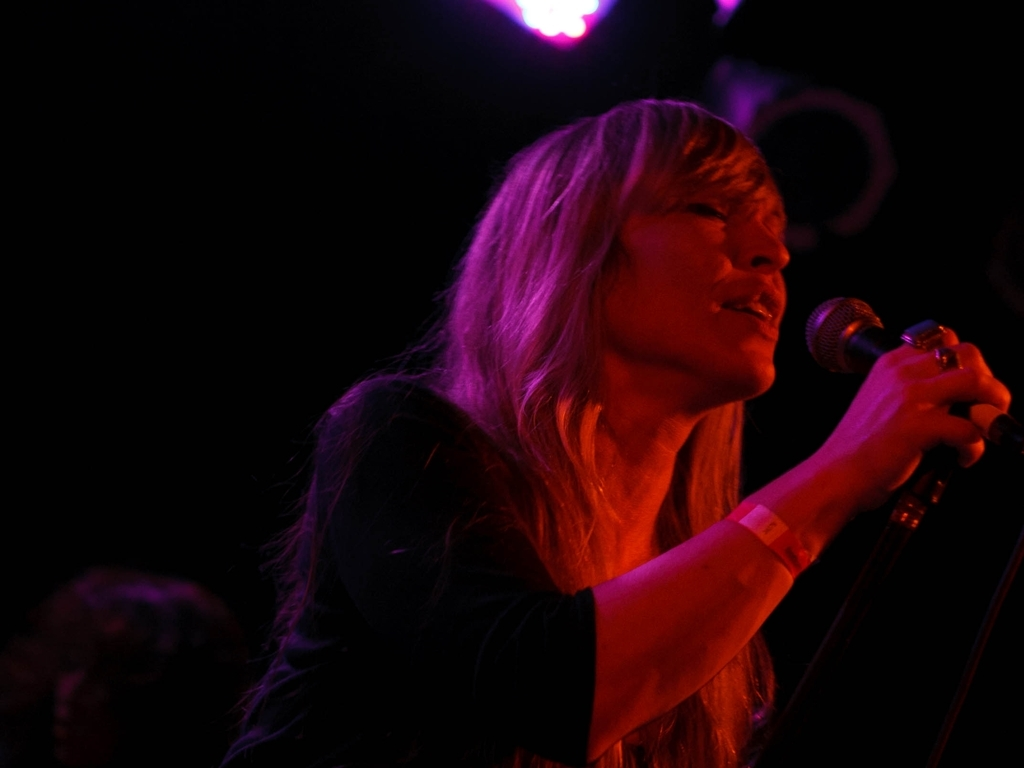How is the lighting from above? The lighting from above appears to be overly warm and a bit harsh, indicating that it may not be well-balanced and could be seen as less natural than desired, especially for photography or videography purposes. It casts strong shadows and seems to be concentrated, which might not be ideal for capturing the subject evenly. 